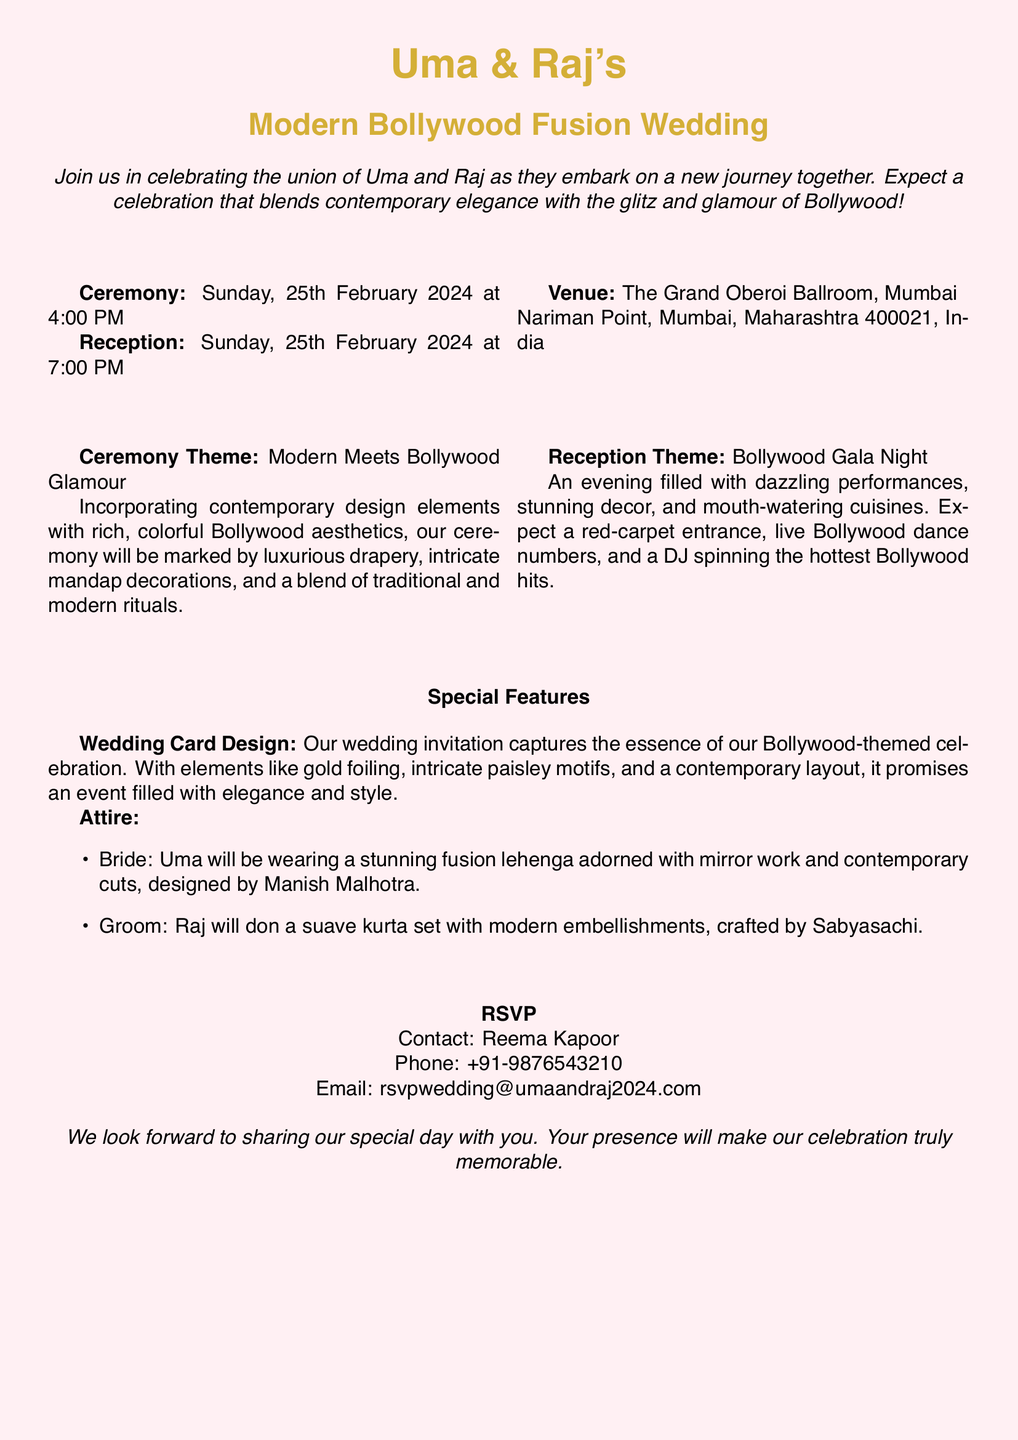What is the date of the wedding ceremony? The date of the ceremony is clearly stated in the document as Sunday, 25th February 2024.
Answer: 25th February 2024 What time does the reception start? The document lists the reception time after the ceremony details, indicating the start time is 7:00 PM.
Answer: 7:00 PM What is the venue for the wedding? The venue is specified in the document as The Grand Oberoi Ballroom, Mumbai.
Answer: The Grand Oberoi Ballroom, Mumbai Who is designing the bride's attire? The document mentions that Uma's lehenga is designed by Manish Malhotra.
Answer: Manish Malhotra What theme combines both the ceremony and reception? The document describes the ceremony theme as "Modern Meets Bollywood Glamour" and the reception theme as "Bollywood Gala Night".
Answer: Bollywood Gala Night What special features are highlighted in the invitation? The document mentions "Wedding Card Design" and "Attire" as special features included in the invitation.
Answer: Wedding Card Design Who should you contact for RSVP? The document specifies Reema Kapoor as the contact person for RSVP.
Answer: Reema Kapoor What will Uma wear to the wedding? The invitation states that Uma will wear a stunning fusion lehenga adorned with mirror work.
Answer: Fusion lehenga What type of entrance can guests expect at the reception? The document mentions an expectation of a "red-carpet entrance" at the reception.
Answer: Red-carpet entrance 